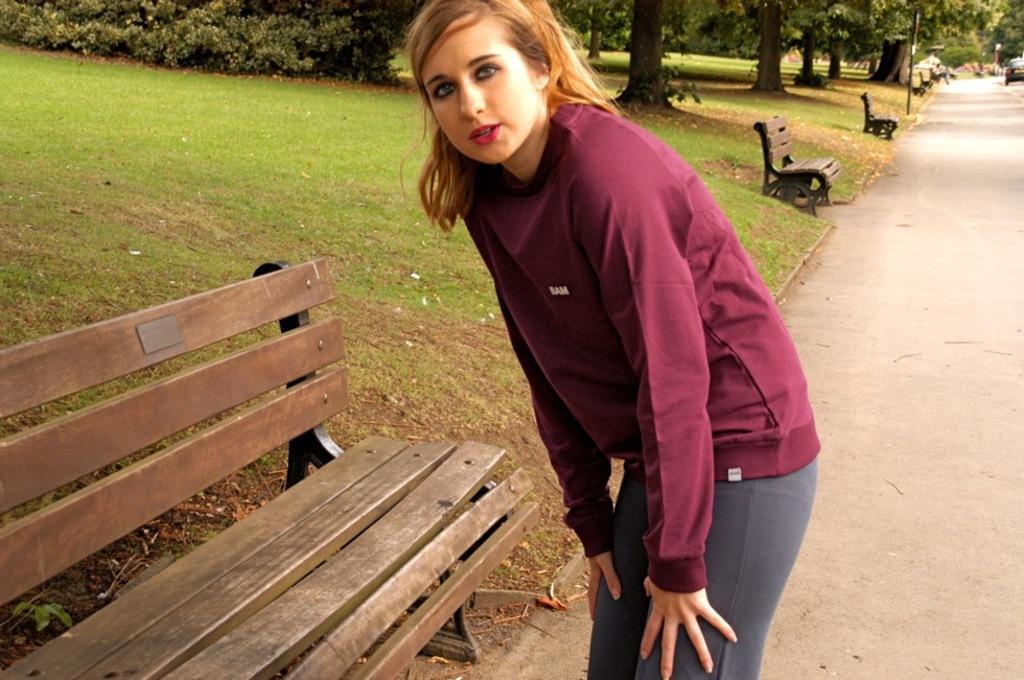How would you summarize this image in a sentence or two? In this image I see a woman who is standing on the path and there is a bench side to her. In the background I see the grass, trees, few benches and a car. 